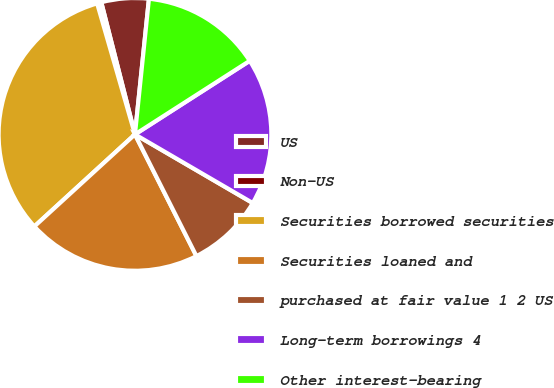<chart> <loc_0><loc_0><loc_500><loc_500><pie_chart><fcel>US<fcel>Non-US<fcel>Securities borrowed securities<fcel>Securities loaned and<fcel>purchased at fair value 1 2 US<fcel>Long-term borrowings 4<fcel>Other interest-bearing<nl><fcel>5.61%<fcel>0.5%<fcel>32.32%<fcel>20.65%<fcel>9.16%<fcel>17.47%<fcel>14.29%<nl></chart> 